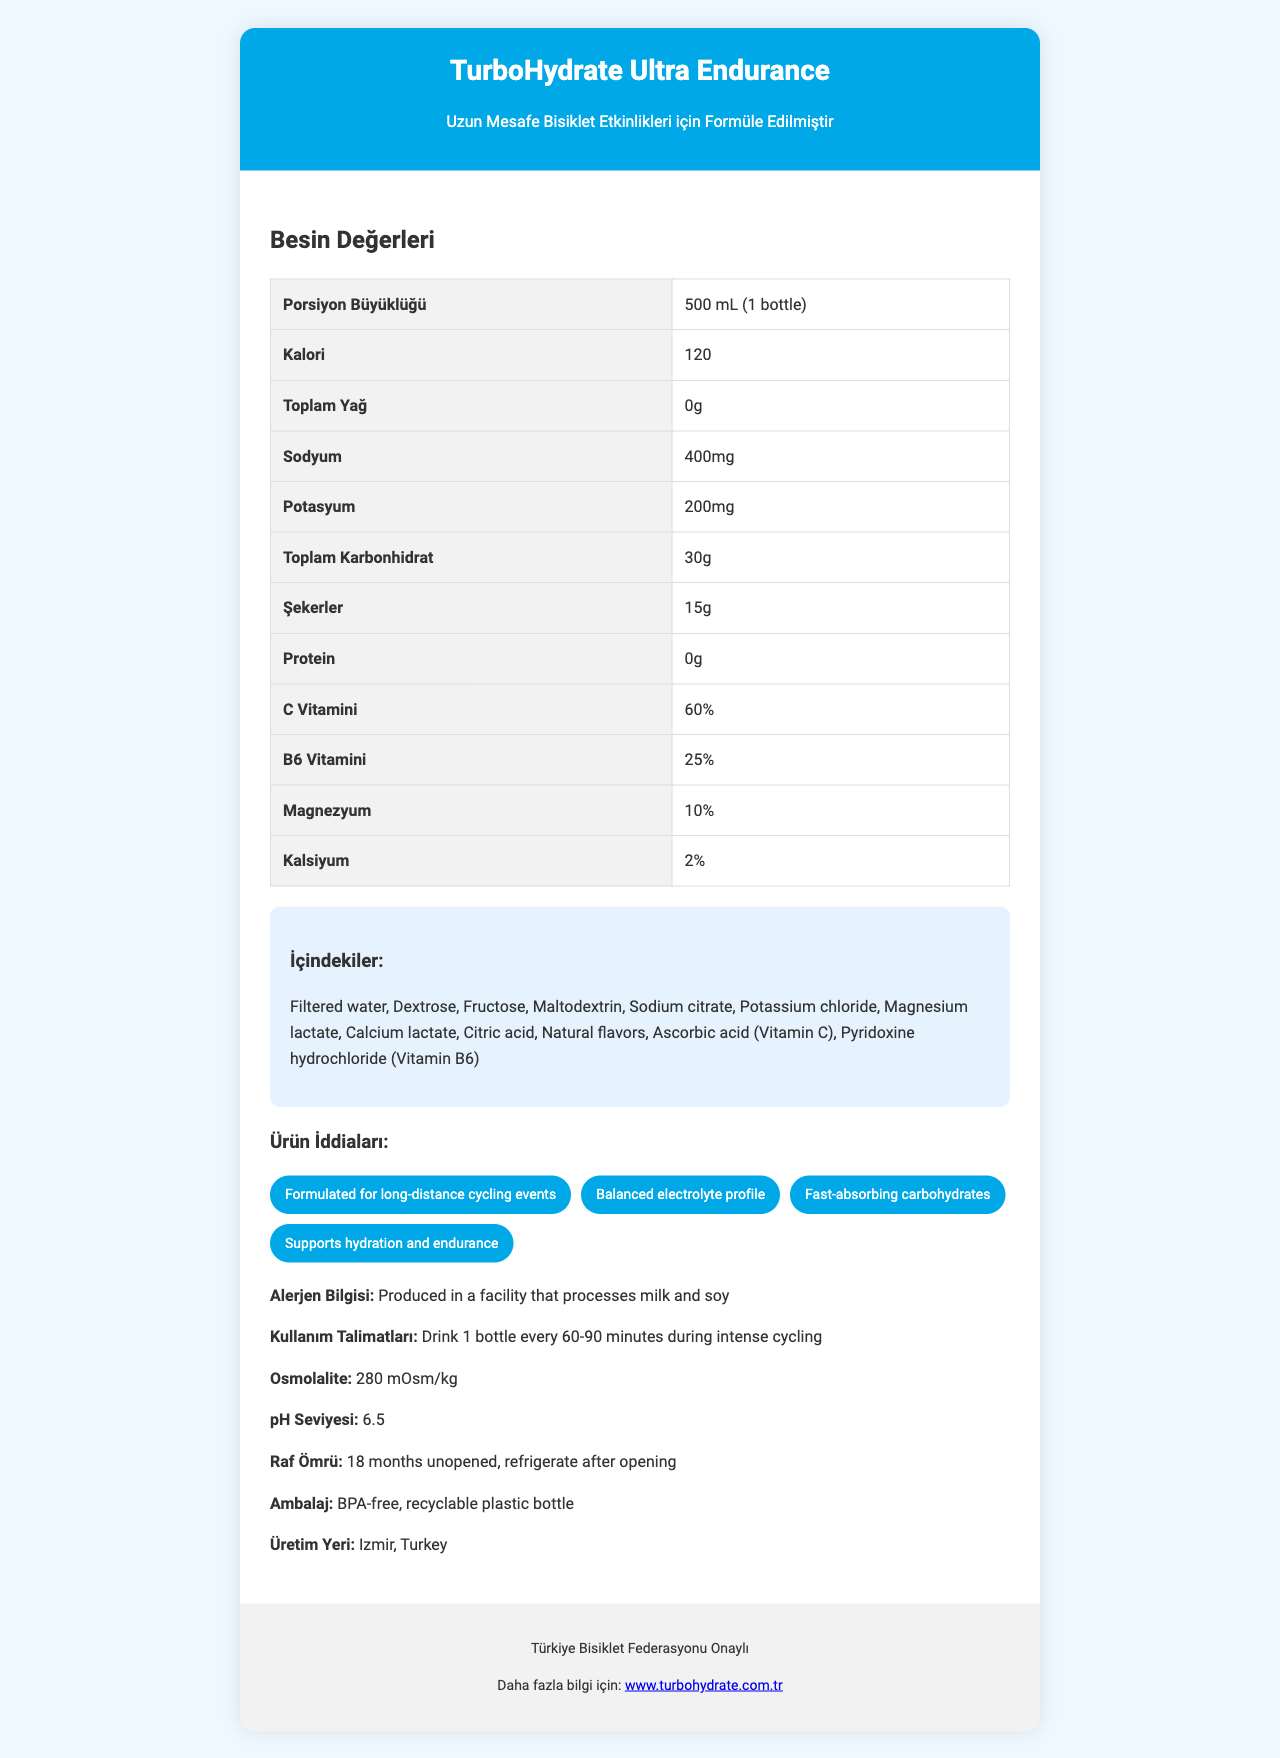What is the serving size of TurboHydrate Ultra Endurance? The serving size is explicitly mentioned as 500 mL (1 bottle) in the document.
Answer: 500 mL (1 bottle) How many calories are there per serving of TurboHydrate Ultra Endurance? The document lists the calorie content as 120 calories per serving.
Answer: 120 calories What is the sodium content in one bottle of TurboHydrate Ultra Endurance? The sodium content is specified as 400 mg in the nutrition facts section.
Answer: 400 mg What is the potassium content in one serving? The potassium content is listed as 200 mg in the document.
Answer: 200 mg Which vitamins are included in TurboHydrate Ultra Endurance, and what are their percentages? The vitamins listed are Vitamin C (60%) and Vitamin B6 (25%).
Answer: Vitamin C (60%), Vitamin B6 (25%) What ingredients are used in TurboHydrate Ultra Endurance? The document contains a detailed list of ingredients used in the product.
Answer: Filtered water, Dextrose, Fructose, Maltodextrin, Sodium citrate, Potassium chloride, Magnesium lactate, Calcium lactate, Citric acid, Natural flavors, Ascorbic acid (Vitamin C), Pyridoxine hydrochloride (Vitamin B6) Which of the following is NOT a claim made about TurboHydrate Ultra Endurance?  
a) Supports hydration and endurance  
b) Contains caffeine for energy boost  
c) Balanced electrolyte profile  
d) Fast-absorbing carbohydrates The document does not mention caffeine for energy boost as one of the claims.
Answer: b) Contains caffeine for energy boost Where is TurboHydrate Ultra Endurance manufactured?  
i) Istanbul, Turkey  
ii) Izmir, Turkey  
iii) Ankara, Turkey The product is manufactured in Izmir, Turkey, as stated in the document.
Answer: ii) Izmir, Turkey Is TurboHydrate Ultra Endurance approved by the Türkiye Cycling Federation? The document explicitly mentions that the product is approved by the Türkiye Cycling Federation.
Answer: Yes What is the osmolality of TurboHydrate Ultra Endurance? The osmolality is clearly indicated as 280 mOsm/kg in the document.
Answer: 280 mOsm/kg What should you do after opening a bottle of TurboHydrate Ultra Endurance? The usage instructions specify that the drink should be refrigerated after opening.
Answer: Refrigerate What is the pH level of TurboHydrate Ultra Endurance? The pH level is mentioned as 6.5 in the document.
Answer: 6.5 How long is the shelf life of TurboHydrate Ultra Endurance when unopened? The shelf life of the product when unopened is 18 months, according to the document.
Answer: 18 months Is TurboHydrate Ultra Endurance produced in a facility that processes milk and soy? The allergen information section states that it is produced in a facility that processes milk and soy.
Answer: Yes Summarize the main information provided in the document about TurboHydrate Ultra Endurance. This summary provides a comprehensive overview of all the main points covered in the document including nutritional content, ingredients, claims, allergen information, and additional specifications.
Answer: TurboHydrate Ultra Endurance is a hydration drink designed for long-distance cycling events, manufactured in Izmir, Turkey. It provides 120 calories per 500 mL serving and includes key electrolytes and vitamins such as sodium, potassium, Vitamin C, and Vitamin B6. The product is approved by the Türkiye Cycling Federation, has an osmolality of 280 mOsm/kg, a pH level of 6.5, and has various claims including balanced electrolytes and fast-absorbing carbohydrates. Refrigeration is required after opening, and it has an 18-month shelf life when unopened. Does TurboHydrate Ultra Endurance contain any caffeine? The document does not provide any information regarding caffeine content, so the answer cannot be determined from the provided information.
Answer: I don't know 